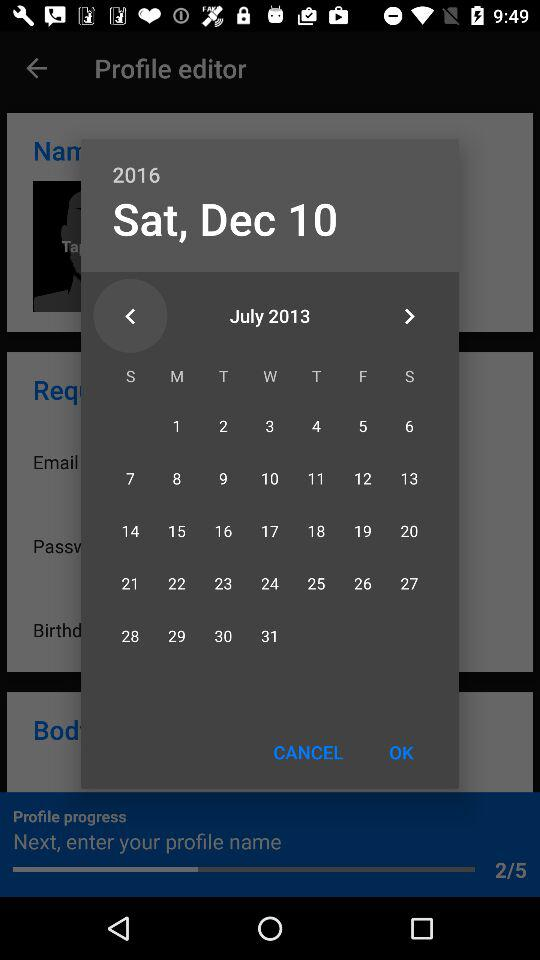What is the total number of steps in "Profile progress"? The total number of steps in "Profile progress" is 5. 